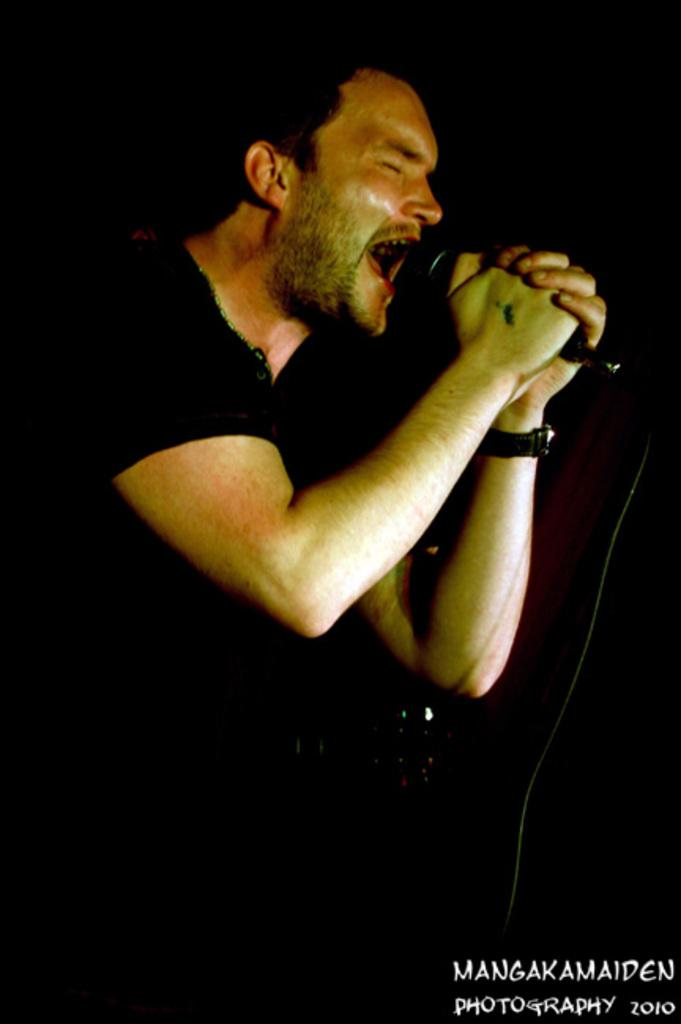Who is the main subject in the image? There is a man in the image. What is the man doing in the image? The man is singing. What object is the man holding in the image? The man is holding a microphone. Where can we find additional information or text in the image? There is text in the bottom right corner of the image. How many cats are visible in the image? There are no cats present in the image. What type of army equipment can be seen in the image? There is no army equipment present in the image. 